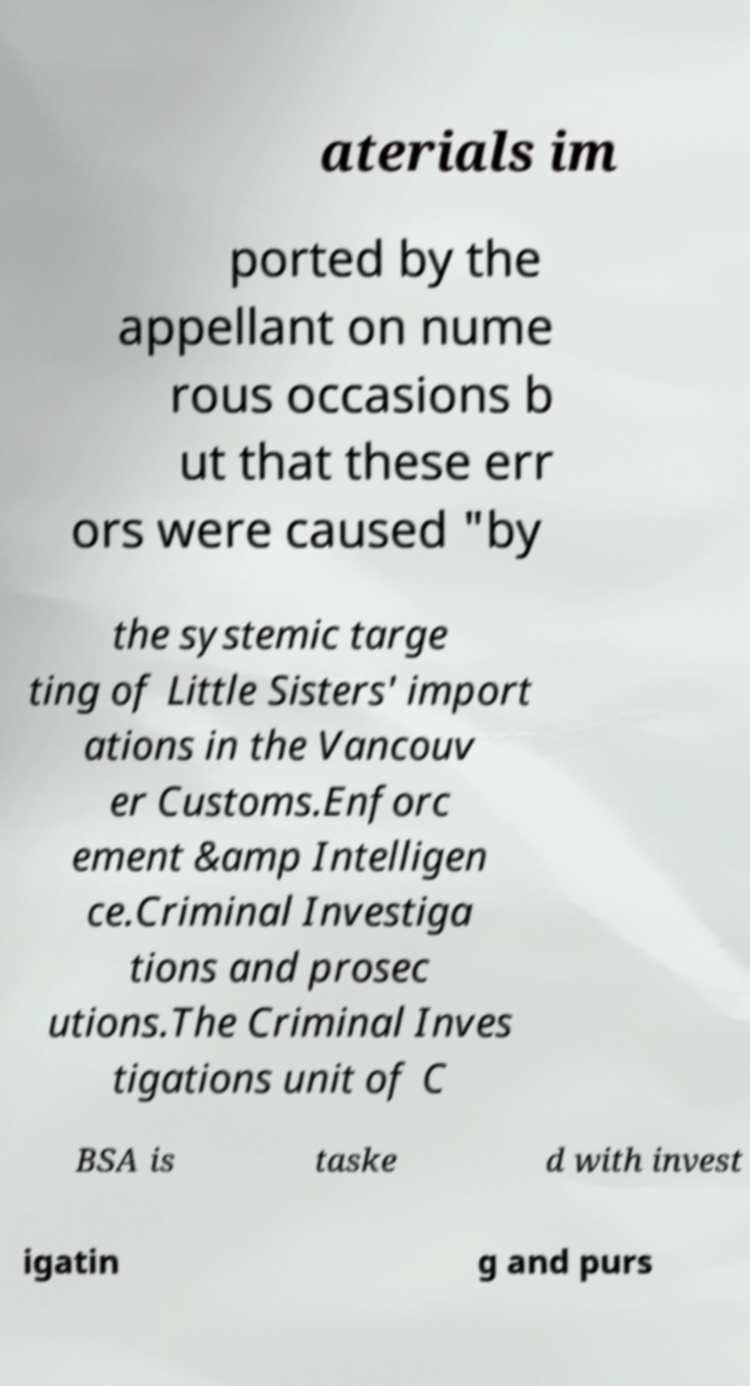Could you assist in decoding the text presented in this image and type it out clearly? aterials im ported by the appellant on nume rous occasions b ut that these err ors were caused "by the systemic targe ting of Little Sisters' import ations in the Vancouv er Customs.Enforc ement &amp Intelligen ce.Criminal Investiga tions and prosec utions.The Criminal Inves tigations unit of C BSA is taske d with invest igatin g and purs 